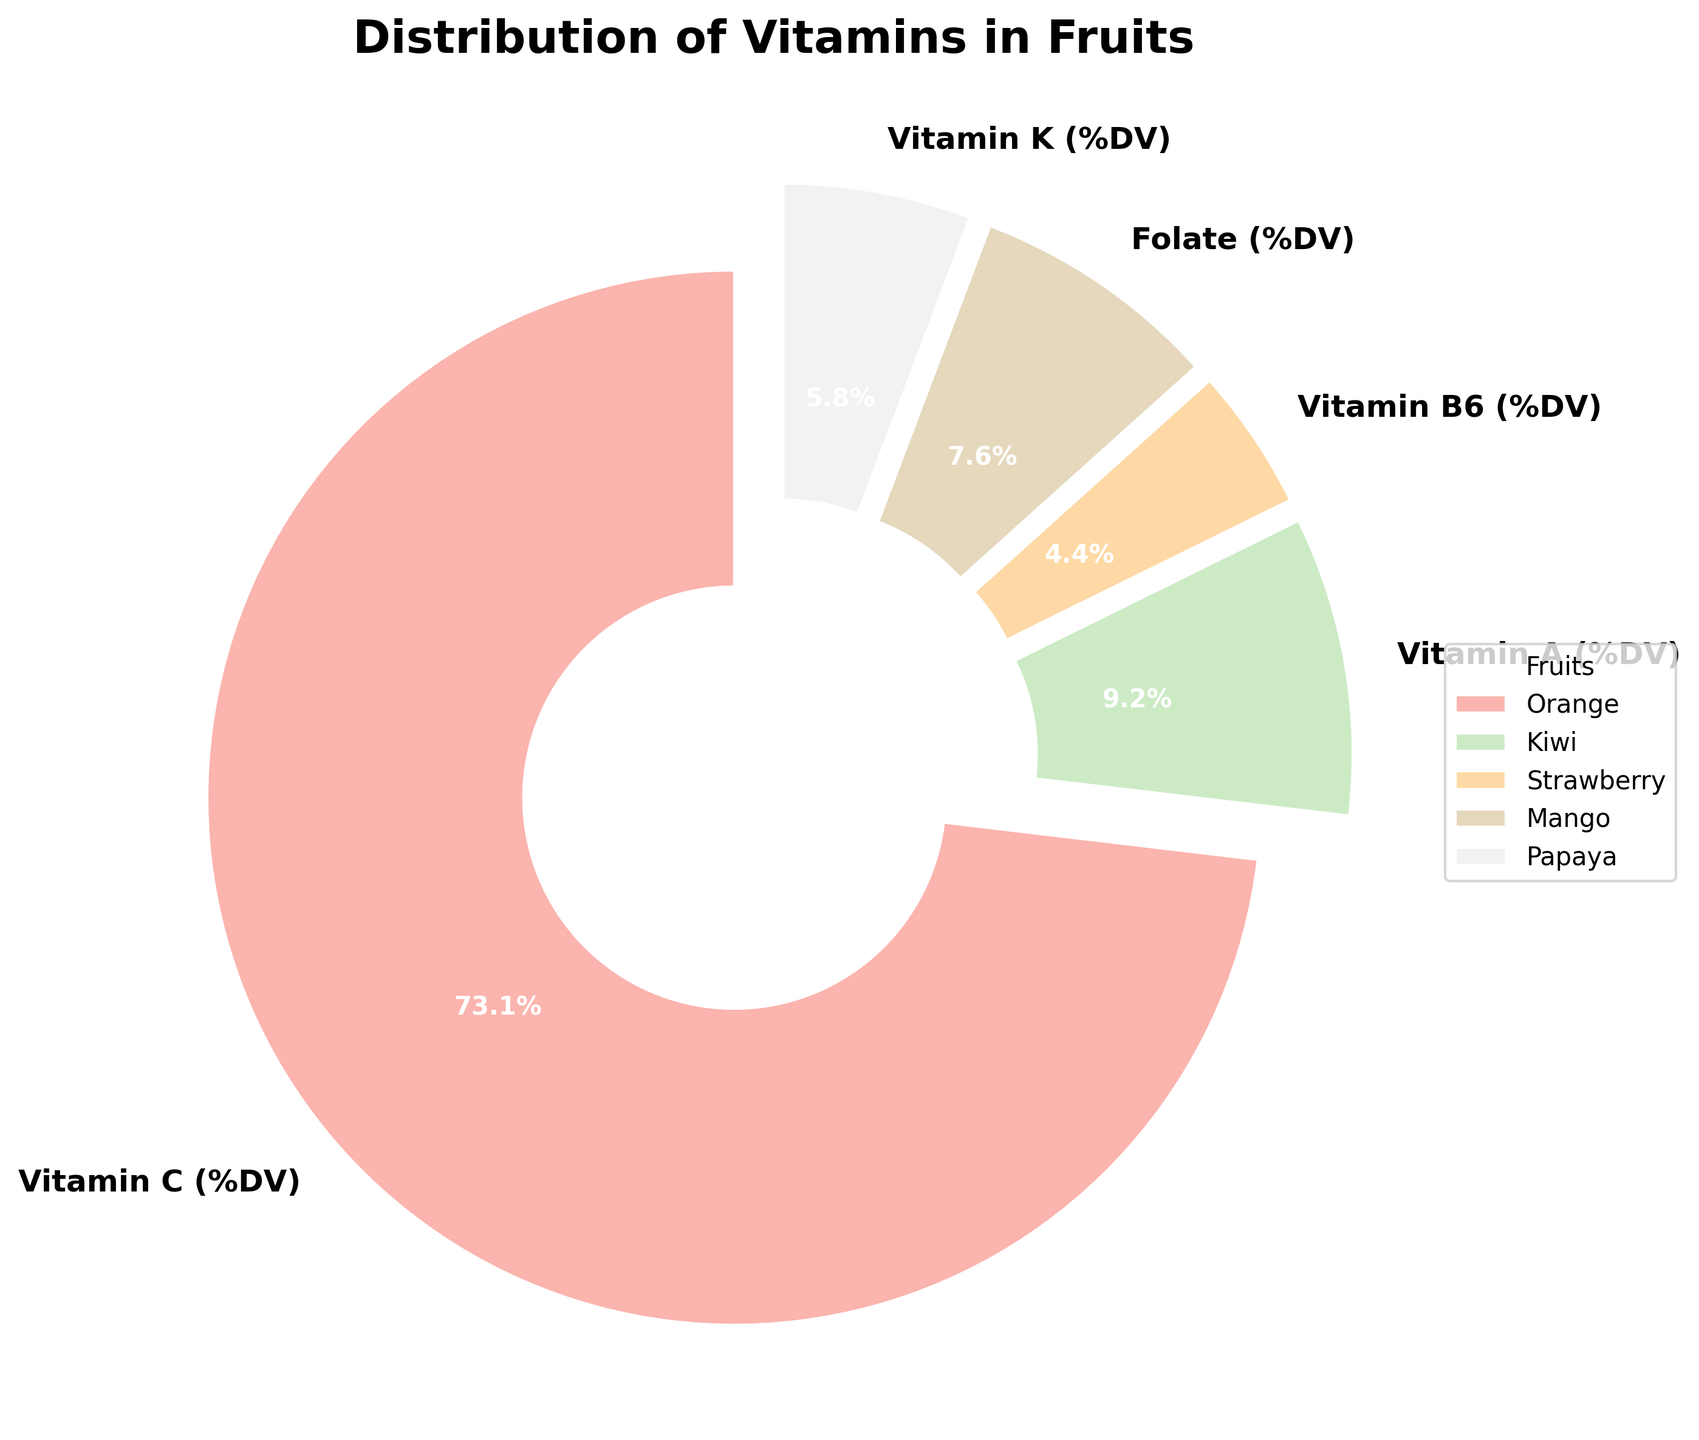What's the largest vitamin component in the fruits? The largest segment in the pie chart represents Vitamin C (%DV). Thus, Vitamin C has the highest percentage of the daily value among the vitamins in the fruit dataset.
Answer: Vitamin C (%DV) Which vitamin has the smallest share in the breakdown? By looking at the smallest segment in the pie chart, we can see that Vitamin B6 (%DV) has the smallest share among the vitamins.
Answer: Vitamin B6 (%DV) How does the share of Vitamin K compare to Vitamin A? The segment representing Vitamin A (%DV) is larger than that of Vitamin K (%DV) in the pie chart, indicating that the share of Vitamin A is greater.
Answer: Vitamin A (%DV) is greater than Vitamin K (%DV) Are there any vitamins that have similar percentages? The pie chart shows that Folate (%DV) and Vitamin K (%DV) have closely sized segments, indicating that their percentages are similar.
Answer: Folate (%DV) and Vitamin K (%DV) What is the second most prevalent vitamin in the fruits? By observing the slices of the pie chart, the second-largest segment after Vitamin C is Vitamin A (%DV).
Answer: Vitamin A (%DV) What's the cumulative percentage of Vitamin A and Vitamin B6? The segments for Vitamin A (%DV) and Vitamin B6 (%DV) represent individual portions of the pie chart. Adding their percentages gives us the cumulative value: Vitamin A = 10.3% + Vitamin B6 = 4.6%, so the total is 10.3% + 4.6% = 14.9%
Answer: 14.9% Which vitamin's segment is slightly more prominent, Vitamin C or Folate? By comparing the sizes of the segments for Vitamin C (%DV) and Folate (%DV), it's clear that Vitamin C (%DV) is larger than Folate (%DV).
Answer: Vitamin C (%DV) What's the combined share of Vitamin C, Folate, and Vitamin K? To find the combined share of Vitamin C (%DV), Folate (%DV), and Vitamin K (%DV), we sum their percentages: Vitamin C = 47.7% + Folate = 10.1% + Vitamin K = 5.3%. The total is 47.7% + 10.1% + 5.3% = 63.1%
Answer: 63.1% 